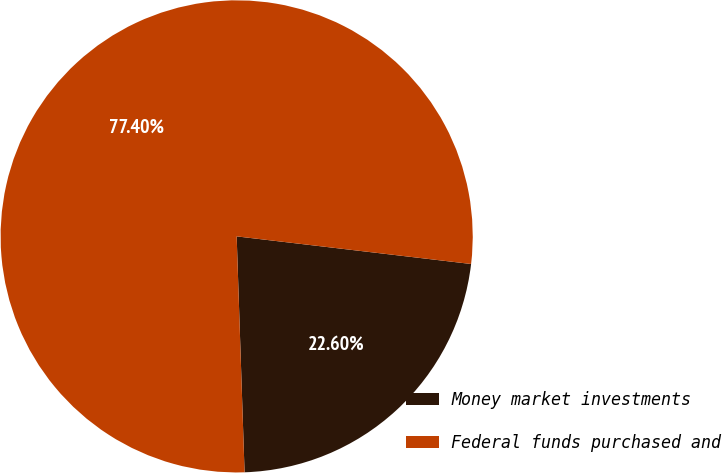<chart> <loc_0><loc_0><loc_500><loc_500><pie_chart><fcel>Money market investments<fcel>Federal funds purchased and<nl><fcel>22.6%<fcel>77.4%<nl></chart> 